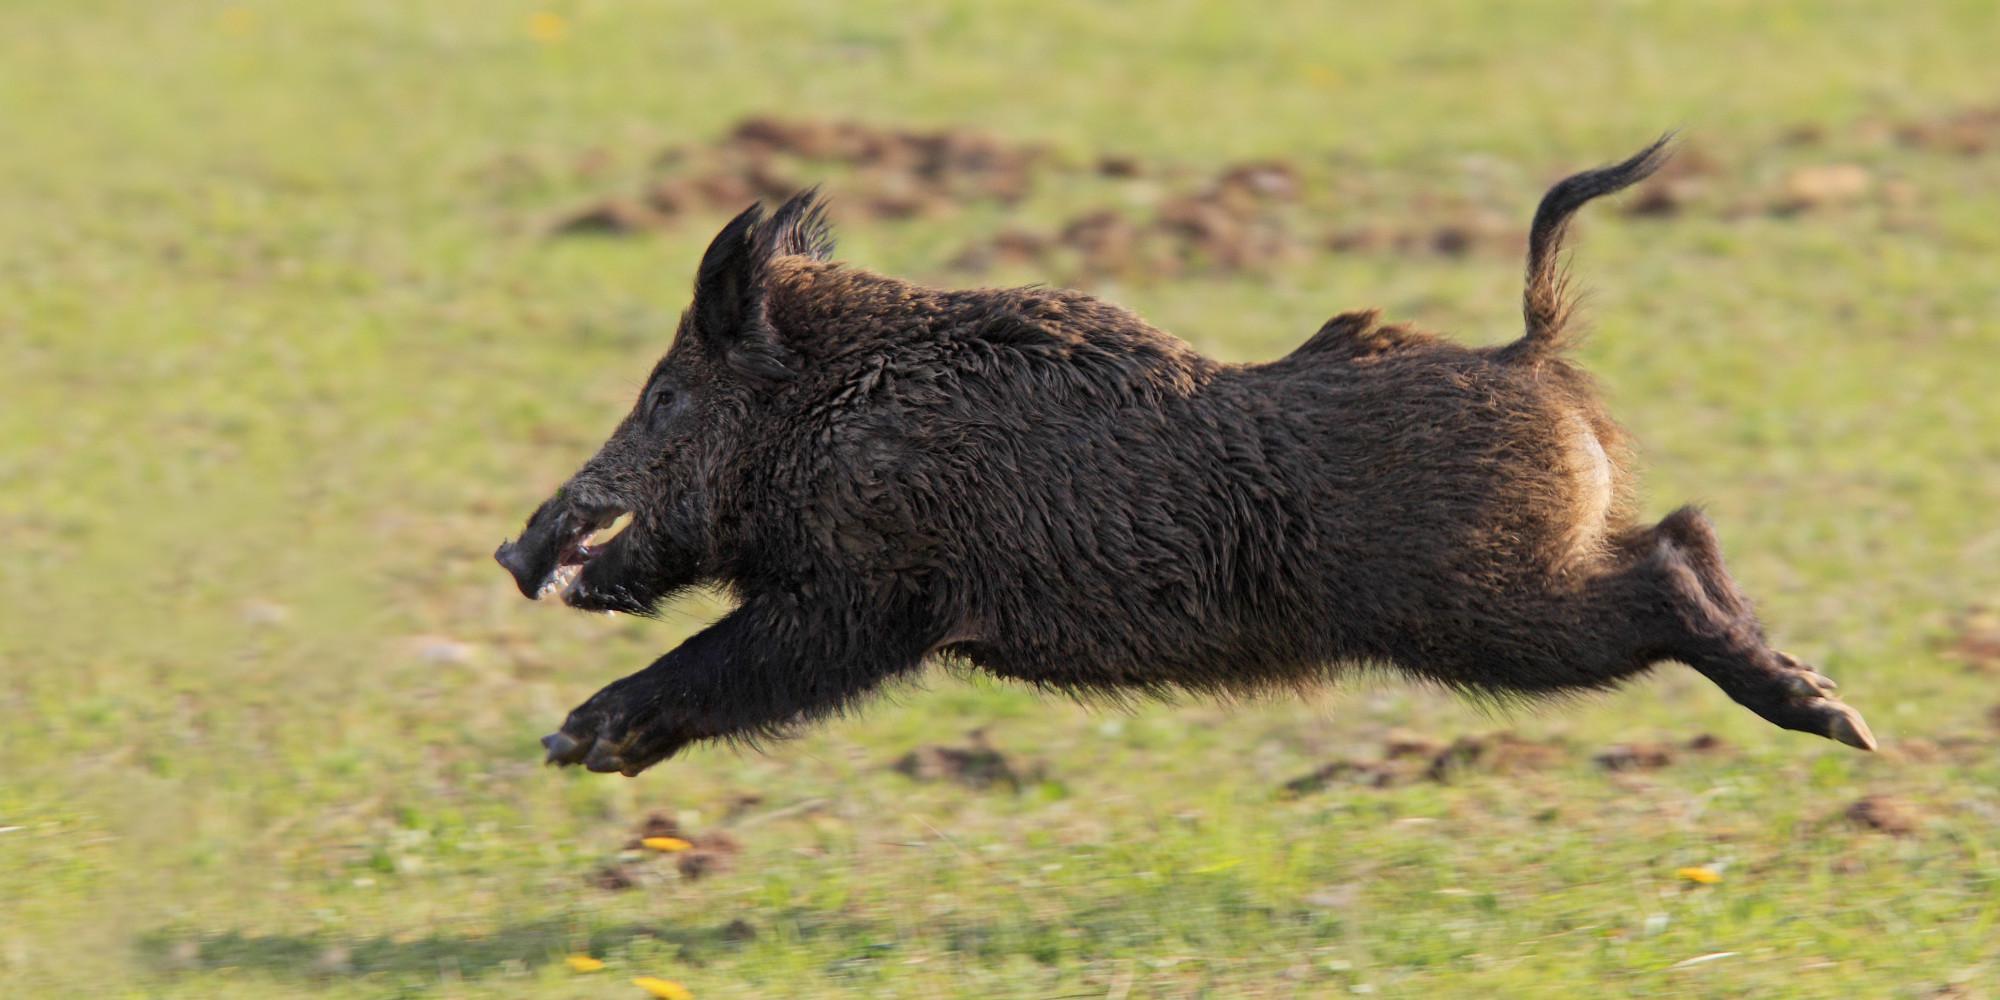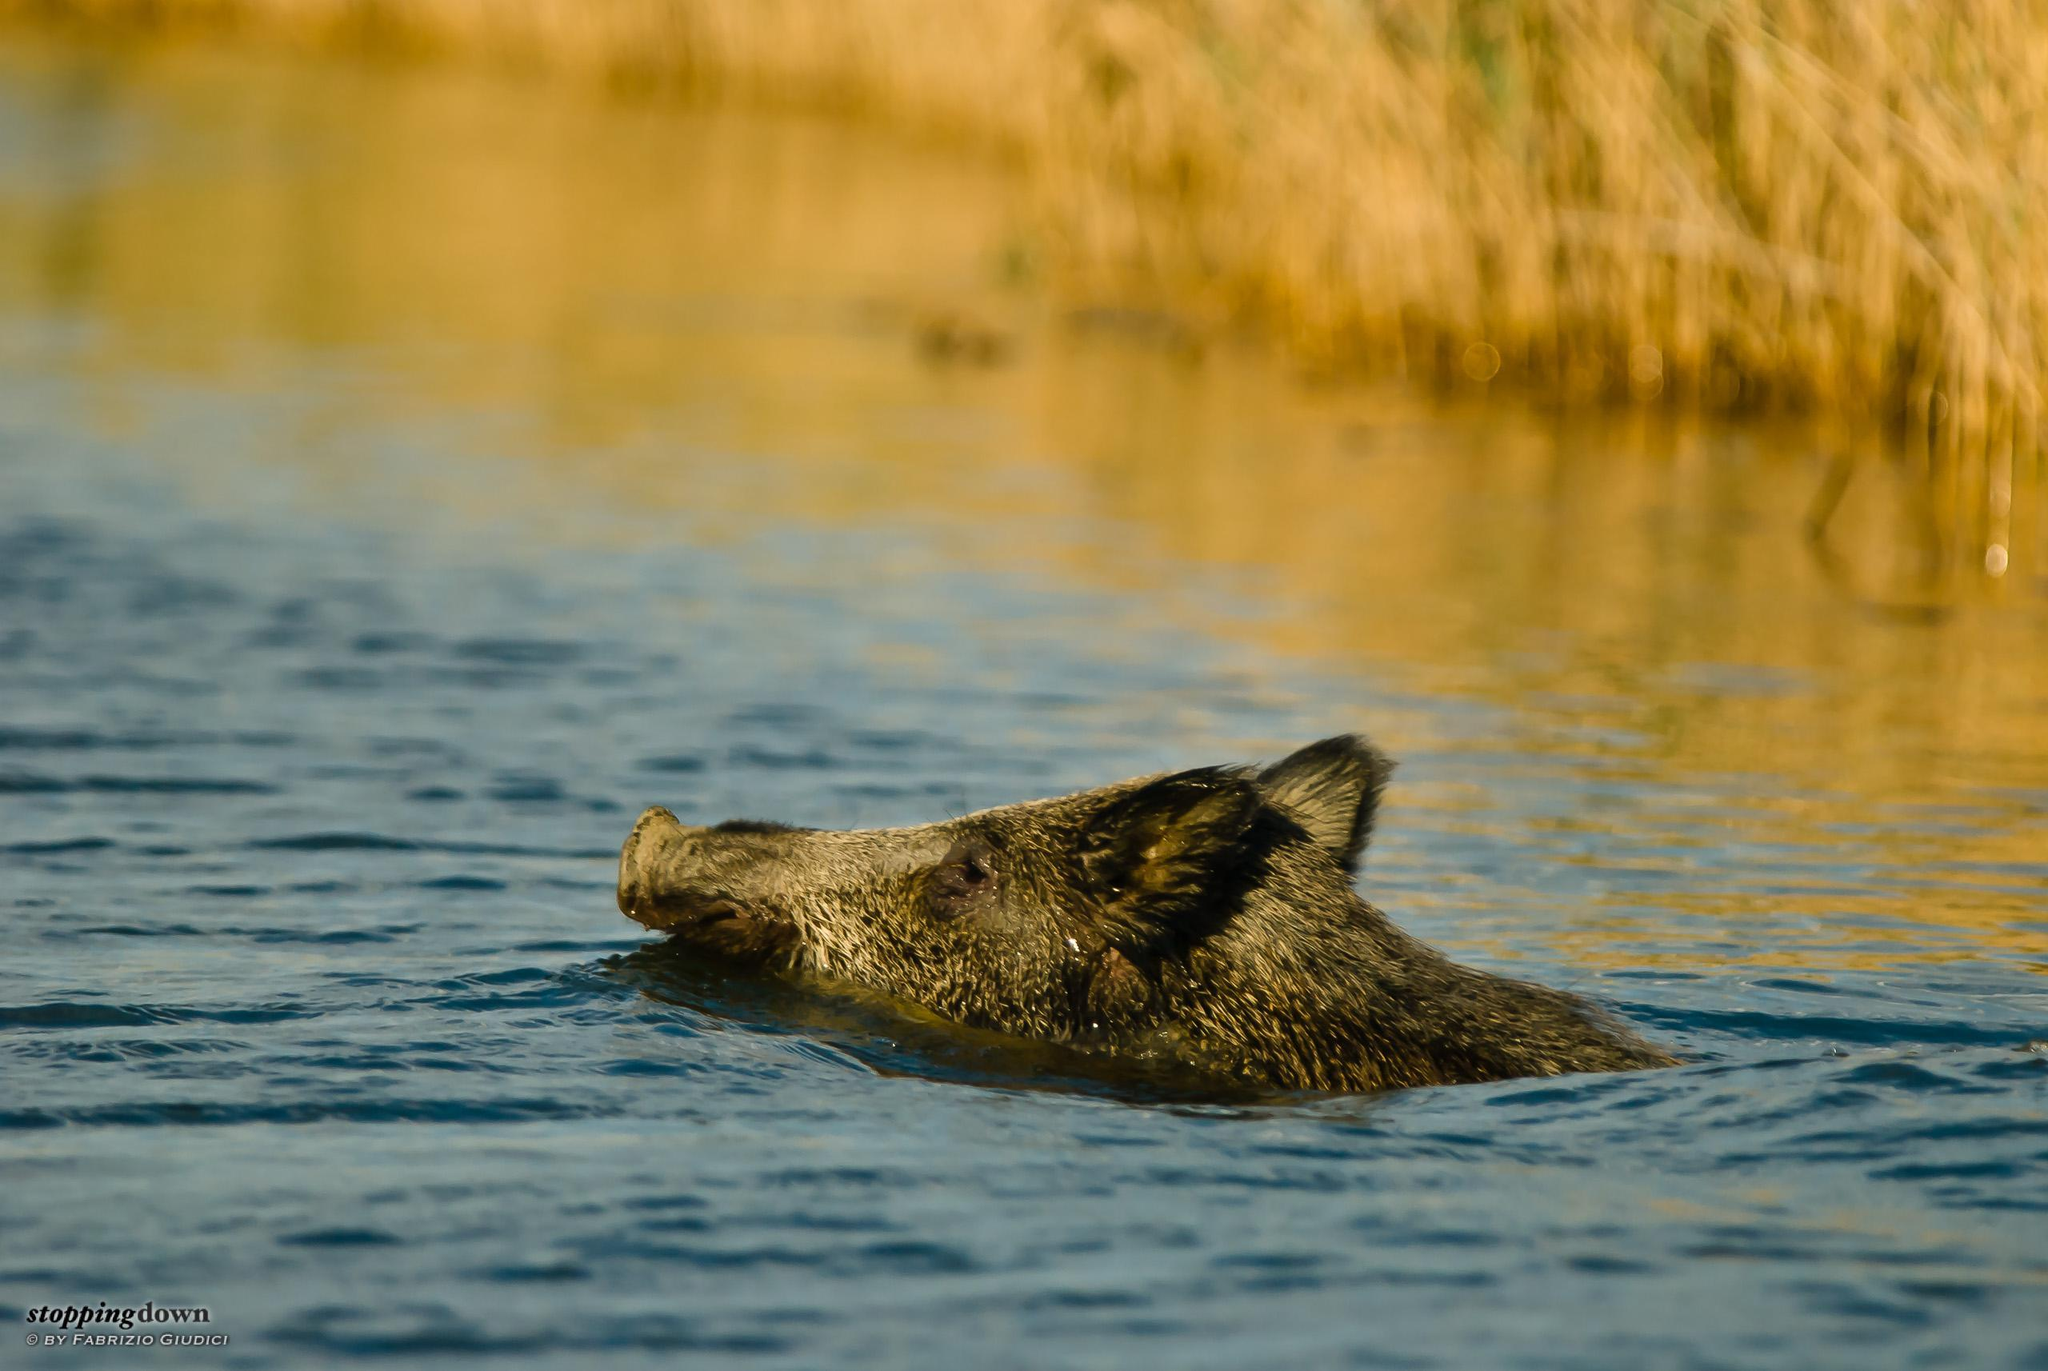The first image is the image on the left, the second image is the image on the right. For the images shown, is this caption "Both images feature pigs in the water." true? Answer yes or no. No. The first image is the image on the left, the second image is the image on the right. Evaluate the accuracy of this statement regarding the images: "All of the hogs are in water and some of them are in crystal blue water.". Is it true? Answer yes or no. No. 